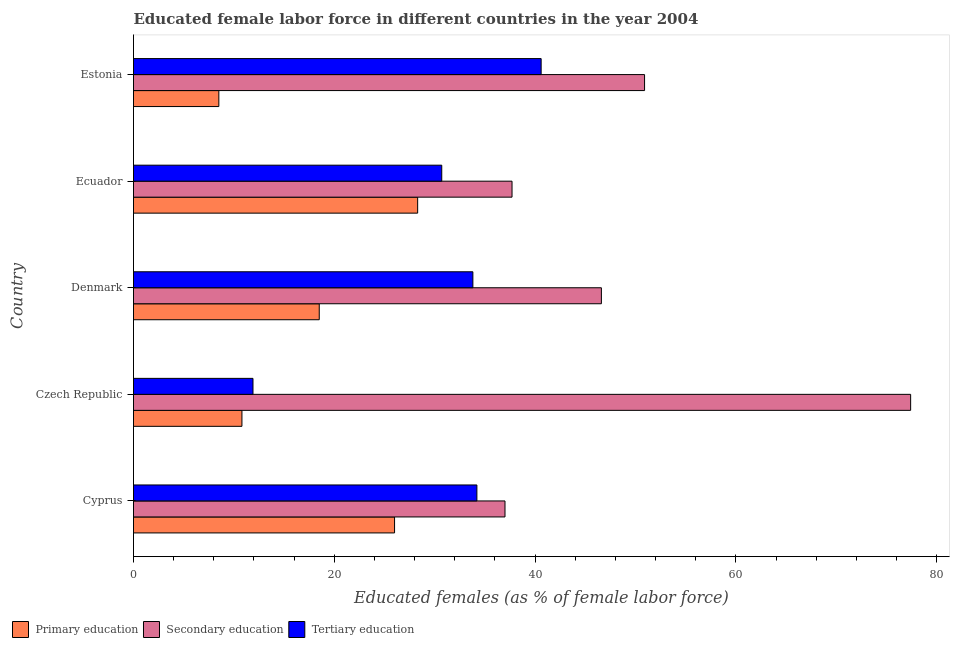Are the number of bars per tick equal to the number of legend labels?
Give a very brief answer. Yes. Are the number of bars on each tick of the Y-axis equal?
Ensure brevity in your answer.  Yes. What is the label of the 5th group of bars from the top?
Keep it short and to the point. Cyprus. What is the percentage of female labor force who received secondary education in Estonia?
Your answer should be very brief. 50.9. Across all countries, what is the maximum percentage of female labor force who received secondary education?
Ensure brevity in your answer.  77.4. Across all countries, what is the minimum percentage of female labor force who received primary education?
Your answer should be very brief. 8.5. In which country was the percentage of female labor force who received secondary education maximum?
Provide a succinct answer. Czech Republic. In which country was the percentage of female labor force who received secondary education minimum?
Provide a succinct answer. Cyprus. What is the total percentage of female labor force who received secondary education in the graph?
Your response must be concise. 249.6. What is the difference between the percentage of female labor force who received tertiary education in Estonia and the percentage of female labor force who received primary education in Ecuador?
Your answer should be compact. 12.3. What is the average percentage of female labor force who received secondary education per country?
Your answer should be compact. 49.92. What is the ratio of the percentage of female labor force who received tertiary education in Denmark to that in Ecuador?
Your answer should be very brief. 1.1. What is the difference between the highest and the second highest percentage of female labor force who received tertiary education?
Give a very brief answer. 6.4. What is the difference between the highest and the lowest percentage of female labor force who received secondary education?
Offer a terse response. 40.4. In how many countries, is the percentage of female labor force who received secondary education greater than the average percentage of female labor force who received secondary education taken over all countries?
Give a very brief answer. 2. Is the sum of the percentage of female labor force who received tertiary education in Czech Republic and Ecuador greater than the maximum percentage of female labor force who received secondary education across all countries?
Provide a short and direct response. No. What does the 3rd bar from the bottom in Estonia represents?
Give a very brief answer. Tertiary education. How many bars are there?
Provide a short and direct response. 15. Are all the bars in the graph horizontal?
Your answer should be compact. Yes. Does the graph contain grids?
Ensure brevity in your answer.  No. Where does the legend appear in the graph?
Provide a succinct answer. Bottom left. What is the title of the graph?
Keep it short and to the point. Educated female labor force in different countries in the year 2004. What is the label or title of the X-axis?
Your answer should be compact. Educated females (as % of female labor force). What is the label or title of the Y-axis?
Ensure brevity in your answer.  Country. What is the Educated females (as % of female labor force) of Primary education in Cyprus?
Provide a succinct answer. 26. What is the Educated females (as % of female labor force) in Tertiary education in Cyprus?
Ensure brevity in your answer.  34.2. What is the Educated females (as % of female labor force) in Primary education in Czech Republic?
Your response must be concise. 10.8. What is the Educated females (as % of female labor force) in Secondary education in Czech Republic?
Give a very brief answer. 77.4. What is the Educated females (as % of female labor force) of Tertiary education in Czech Republic?
Your answer should be compact. 11.9. What is the Educated females (as % of female labor force) in Primary education in Denmark?
Your answer should be very brief. 18.5. What is the Educated females (as % of female labor force) of Secondary education in Denmark?
Offer a terse response. 46.6. What is the Educated females (as % of female labor force) in Tertiary education in Denmark?
Keep it short and to the point. 33.8. What is the Educated females (as % of female labor force) in Primary education in Ecuador?
Provide a short and direct response. 28.3. What is the Educated females (as % of female labor force) in Secondary education in Ecuador?
Ensure brevity in your answer.  37.7. What is the Educated females (as % of female labor force) of Tertiary education in Ecuador?
Your response must be concise. 30.7. What is the Educated females (as % of female labor force) in Primary education in Estonia?
Ensure brevity in your answer.  8.5. What is the Educated females (as % of female labor force) in Secondary education in Estonia?
Your answer should be very brief. 50.9. What is the Educated females (as % of female labor force) in Tertiary education in Estonia?
Provide a succinct answer. 40.6. Across all countries, what is the maximum Educated females (as % of female labor force) in Primary education?
Ensure brevity in your answer.  28.3. Across all countries, what is the maximum Educated females (as % of female labor force) of Secondary education?
Your answer should be very brief. 77.4. Across all countries, what is the maximum Educated females (as % of female labor force) of Tertiary education?
Provide a succinct answer. 40.6. Across all countries, what is the minimum Educated females (as % of female labor force) in Primary education?
Provide a succinct answer. 8.5. Across all countries, what is the minimum Educated females (as % of female labor force) in Secondary education?
Ensure brevity in your answer.  37. Across all countries, what is the minimum Educated females (as % of female labor force) of Tertiary education?
Give a very brief answer. 11.9. What is the total Educated females (as % of female labor force) of Primary education in the graph?
Provide a succinct answer. 92.1. What is the total Educated females (as % of female labor force) in Secondary education in the graph?
Your response must be concise. 249.6. What is the total Educated females (as % of female labor force) of Tertiary education in the graph?
Make the answer very short. 151.2. What is the difference between the Educated females (as % of female labor force) of Primary education in Cyprus and that in Czech Republic?
Make the answer very short. 15.2. What is the difference between the Educated females (as % of female labor force) of Secondary education in Cyprus and that in Czech Republic?
Provide a short and direct response. -40.4. What is the difference between the Educated females (as % of female labor force) in Tertiary education in Cyprus and that in Czech Republic?
Offer a terse response. 22.3. What is the difference between the Educated females (as % of female labor force) in Secondary education in Cyprus and that in Denmark?
Offer a terse response. -9.6. What is the difference between the Educated females (as % of female labor force) of Tertiary education in Cyprus and that in Denmark?
Your answer should be very brief. 0.4. What is the difference between the Educated females (as % of female labor force) in Tertiary education in Cyprus and that in Ecuador?
Give a very brief answer. 3.5. What is the difference between the Educated females (as % of female labor force) of Primary education in Czech Republic and that in Denmark?
Make the answer very short. -7.7. What is the difference between the Educated females (as % of female labor force) of Secondary education in Czech Republic and that in Denmark?
Keep it short and to the point. 30.8. What is the difference between the Educated females (as % of female labor force) of Tertiary education in Czech Republic and that in Denmark?
Ensure brevity in your answer.  -21.9. What is the difference between the Educated females (as % of female labor force) in Primary education in Czech Republic and that in Ecuador?
Keep it short and to the point. -17.5. What is the difference between the Educated females (as % of female labor force) in Secondary education in Czech Republic and that in Ecuador?
Your answer should be compact. 39.7. What is the difference between the Educated females (as % of female labor force) of Tertiary education in Czech Republic and that in Ecuador?
Offer a very short reply. -18.8. What is the difference between the Educated females (as % of female labor force) in Primary education in Czech Republic and that in Estonia?
Ensure brevity in your answer.  2.3. What is the difference between the Educated females (as % of female labor force) in Tertiary education in Czech Republic and that in Estonia?
Offer a terse response. -28.7. What is the difference between the Educated females (as % of female labor force) of Secondary education in Denmark and that in Estonia?
Make the answer very short. -4.3. What is the difference between the Educated females (as % of female labor force) in Primary education in Ecuador and that in Estonia?
Offer a terse response. 19.8. What is the difference between the Educated females (as % of female labor force) in Tertiary education in Ecuador and that in Estonia?
Make the answer very short. -9.9. What is the difference between the Educated females (as % of female labor force) in Primary education in Cyprus and the Educated females (as % of female labor force) in Secondary education in Czech Republic?
Give a very brief answer. -51.4. What is the difference between the Educated females (as % of female labor force) of Primary education in Cyprus and the Educated females (as % of female labor force) of Tertiary education in Czech Republic?
Provide a succinct answer. 14.1. What is the difference between the Educated females (as % of female labor force) in Secondary education in Cyprus and the Educated females (as % of female labor force) in Tertiary education in Czech Republic?
Ensure brevity in your answer.  25.1. What is the difference between the Educated females (as % of female labor force) in Primary education in Cyprus and the Educated females (as % of female labor force) in Secondary education in Denmark?
Offer a terse response. -20.6. What is the difference between the Educated females (as % of female labor force) of Primary education in Cyprus and the Educated females (as % of female labor force) of Tertiary education in Ecuador?
Give a very brief answer. -4.7. What is the difference between the Educated females (as % of female labor force) in Primary education in Cyprus and the Educated females (as % of female labor force) in Secondary education in Estonia?
Give a very brief answer. -24.9. What is the difference between the Educated females (as % of female labor force) in Primary education in Cyprus and the Educated females (as % of female labor force) in Tertiary education in Estonia?
Your answer should be compact. -14.6. What is the difference between the Educated females (as % of female labor force) in Secondary education in Cyprus and the Educated females (as % of female labor force) in Tertiary education in Estonia?
Give a very brief answer. -3.6. What is the difference between the Educated females (as % of female labor force) of Primary education in Czech Republic and the Educated females (as % of female labor force) of Secondary education in Denmark?
Provide a succinct answer. -35.8. What is the difference between the Educated females (as % of female labor force) of Secondary education in Czech Republic and the Educated females (as % of female labor force) of Tertiary education in Denmark?
Your answer should be very brief. 43.6. What is the difference between the Educated females (as % of female labor force) in Primary education in Czech Republic and the Educated females (as % of female labor force) in Secondary education in Ecuador?
Make the answer very short. -26.9. What is the difference between the Educated females (as % of female labor force) in Primary education in Czech Republic and the Educated females (as % of female labor force) in Tertiary education in Ecuador?
Keep it short and to the point. -19.9. What is the difference between the Educated females (as % of female labor force) in Secondary education in Czech Republic and the Educated females (as % of female labor force) in Tertiary education in Ecuador?
Provide a succinct answer. 46.7. What is the difference between the Educated females (as % of female labor force) in Primary education in Czech Republic and the Educated females (as % of female labor force) in Secondary education in Estonia?
Provide a short and direct response. -40.1. What is the difference between the Educated females (as % of female labor force) in Primary education in Czech Republic and the Educated females (as % of female labor force) in Tertiary education in Estonia?
Provide a succinct answer. -29.8. What is the difference between the Educated females (as % of female labor force) in Secondary education in Czech Republic and the Educated females (as % of female labor force) in Tertiary education in Estonia?
Ensure brevity in your answer.  36.8. What is the difference between the Educated females (as % of female labor force) in Primary education in Denmark and the Educated females (as % of female labor force) in Secondary education in Ecuador?
Keep it short and to the point. -19.2. What is the difference between the Educated females (as % of female labor force) of Secondary education in Denmark and the Educated females (as % of female labor force) of Tertiary education in Ecuador?
Give a very brief answer. 15.9. What is the difference between the Educated females (as % of female labor force) in Primary education in Denmark and the Educated females (as % of female labor force) in Secondary education in Estonia?
Your answer should be very brief. -32.4. What is the difference between the Educated females (as % of female labor force) of Primary education in Denmark and the Educated females (as % of female labor force) of Tertiary education in Estonia?
Give a very brief answer. -22.1. What is the difference between the Educated females (as % of female labor force) in Secondary education in Denmark and the Educated females (as % of female labor force) in Tertiary education in Estonia?
Ensure brevity in your answer.  6. What is the difference between the Educated females (as % of female labor force) in Primary education in Ecuador and the Educated females (as % of female labor force) in Secondary education in Estonia?
Provide a succinct answer. -22.6. What is the difference between the Educated females (as % of female labor force) in Primary education in Ecuador and the Educated females (as % of female labor force) in Tertiary education in Estonia?
Provide a short and direct response. -12.3. What is the average Educated females (as % of female labor force) in Primary education per country?
Provide a short and direct response. 18.42. What is the average Educated females (as % of female labor force) of Secondary education per country?
Keep it short and to the point. 49.92. What is the average Educated females (as % of female labor force) of Tertiary education per country?
Your response must be concise. 30.24. What is the difference between the Educated females (as % of female labor force) of Primary education and Educated females (as % of female labor force) of Secondary education in Czech Republic?
Give a very brief answer. -66.6. What is the difference between the Educated females (as % of female labor force) of Primary education and Educated females (as % of female labor force) of Tertiary education in Czech Republic?
Offer a terse response. -1.1. What is the difference between the Educated females (as % of female labor force) of Secondary education and Educated females (as % of female labor force) of Tertiary education in Czech Republic?
Give a very brief answer. 65.5. What is the difference between the Educated females (as % of female labor force) of Primary education and Educated females (as % of female labor force) of Secondary education in Denmark?
Offer a terse response. -28.1. What is the difference between the Educated females (as % of female labor force) in Primary education and Educated females (as % of female labor force) in Tertiary education in Denmark?
Offer a terse response. -15.3. What is the difference between the Educated females (as % of female labor force) of Primary education and Educated females (as % of female labor force) of Tertiary education in Ecuador?
Your answer should be very brief. -2.4. What is the difference between the Educated females (as % of female labor force) of Secondary education and Educated females (as % of female labor force) of Tertiary education in Ecuador?
Ensure brevity in your answer.  7. What is the difference between the Educated females (as % of female labor force) of Primary education and Educated females (as % of female labor force) of Secondary education in Estonia?
Offer a very short reply. -42.4. What is the difference between the Educated females (as % of female labor force) of Primary education and Educated females (as % of female labor force) of Tertiary education in Estonia?
Offer a terse response. -32.1. What is the ratio of the Educated females (as % of female labor force) of Primary education in Cyprus to that in Czech Republic?
Keep it short and to the point. 2.41. What is the ratio of the Educated females (as % of female labor force) in Secondary education in Cyprus to that in Czech Republic?
Your answer should be very brief. 0.48. What is the ratio of the Educated females (as % of female labor force) of Tertiary education in Cyprus to that in Czech Republic?
Provide a succinct answer. 2.87. What is the ratio of the Educated females (as % of female labor force) in Primary education in Cyprus to that in Denmark?
Provide a short and direct response. 1.41. What is the ratio of the Educated females (as % of female labor force) in Secondary education in Cyprus to that in Denmark?
Ensure brevity in your answer.  0.79. What is the ratio of the Educated females (as % of female labor force) of Tertiary education in Cyprus to that in Denmark?
Your response must be concise. 1.01. What is the ratio of the Educated females (as % of female labor force) of Primary education in Cyprus to that in Ecuador?
Provide a succinct answer. 0.92. What is the ratio of the Educated females (as % of female labor force) of Secondary education in Cyprus to that in Ecuador?
Your answer should be very brief. 0.98. What is the ratio of the Educated females (as % of female labor force) in Tertiary education in Cyprus to that in Ecuador?
Ensure brevity in your answer.  1.11. What is the ratio of the Educated females (as % of female labor force) in Primary education in Cyprus to that in Estonia?
Keep it short and to the point. 3.06. What is the ratio of the Educated females (as % of female labor force) in Secondary education in Cyprus to that in Estonia?
Offer a very short reply. 0.73. What is the ratio of the Educated females (as % of female labor force) of Tertiary education in Cyprus to that in Estonia?
Provide a succinct answer. 0.84. What is the ratio of the Educated females (as % of female labor force) of Primary education in Czech Republic to that in Denmark?
Provide a short and direct response. 0.58. What is the ratio of the Educated females (as % of female labor force) in Secondary education in Czech Republic to that in Denmark?
Make the answer very short. 1.66. What is the ratio of the Educated females (as % of female labor force) in Tertiary education in Czech Republic to that in Denmark?
Provide a succinct answer. 0.35. What is the ratio of the Educated females (as % of female labor force) of Primary education in Czech Republic to that in Ecuador?
Make the answer very short. 0.38. What is the ratio of the Educated females (as % of female labor force) in Secondary education in Czech Republic to that in Ecuador?
Your answer should be very brief. 2.05. What is the ratio of the Educated females (as % of female labor force) of Tertiary education in Czech Republic to that in Ecuador?
Provide a short and direct response. 0.39. What is the ratio of the Educated females (as % of female labor force) of Primary education in Czech Republic to that in Estonia?
Provide a succinct answer. 1.27. What is the ratio of the Educated females (as % of female labor force) of Secondary education in Czech Republic to that in Estonia?
Make the answer very short. 1.52. What is the ratio of the Educated females (as % of female labor force) of Tertiary education in Czech Republic to that in Estonia?
Offer a very short reply. 0.29. What is the ratio of the Educated females (as % of female labor force) in Primary education in Denmark to that in Ecuador?
Offer a terse response. 0.65. What is the ratio of the Educated females (as % of female labor force) of Secondary education in Denmark to that in Ecuador?
Your response must be concise. 1.24. What is the ratio of the Educated females (as % of female labor force) of Tertiary education in Denmark to that in Ecuador?
Your response must be concise. 1.1. What is the ratio of the Educated females (as % of female labor force) in Primary education in Denmark to that in Estonia?
Offer a very short reply. 2.18. What is the ratio of the Educated females (as % of female labor force) in Secondary education in Denmark to that in Estonia?
Provide a succinct answer. 0.92. What is the ratio of the Educated females (as % of female labor force) of Tertiary education in Denmark to that in Estonia?
Keep it short and to the point. 0.83. What is the ratio of the Educated females (as % of female labor force) of Primary education in Ecuador to that in Estonia?
Ensure brevity in your answer.  3.33. What is the ratio of the Educated females (as % of female labor force) in Secondary education in Ecuador to that in Estonia?
Offer a terse response. 0.74. What is the ratio of the Educated females (as % of female labor force) in Tertiary education in Ecuador to that in Estonia?
Your answer should be compact. 0.76. What is the difference between the highest and the second highest Educated females (as % of female labor force) in Primary education?
Your answer should be very brief. 2.3. What is the difference between the highest and the lowest Educated females (as % of female labor force) in Primary education?
Ensure brevity in your answer.  19.8. What is the difference between the highest and the lowest Educated females (as % of female labor force) in Secondary education?
Your answer should be very brief. 40.4. What is the difference between the highest and the lowest Educated females (as % of female labor force) in Tertiary education?
Offer a very short reply. 28.7. 